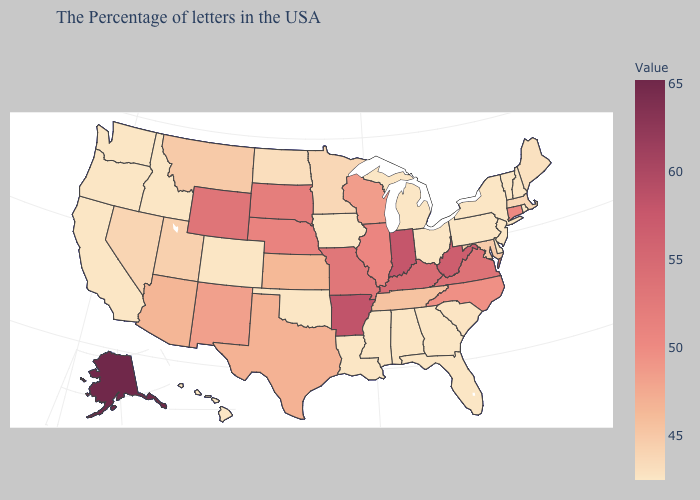Among the states that border Idaho , which have the lowest value?
Short answer required. Washington, Oregon. Which states have the highest value in the USA?
Answer briefly. Alaska. Among the states that border Oklahoma , does Colorado have the highest value?
Short answer required. No. Does Wisconsin have a lower value than Hawaii?
Keep it brief. No. 